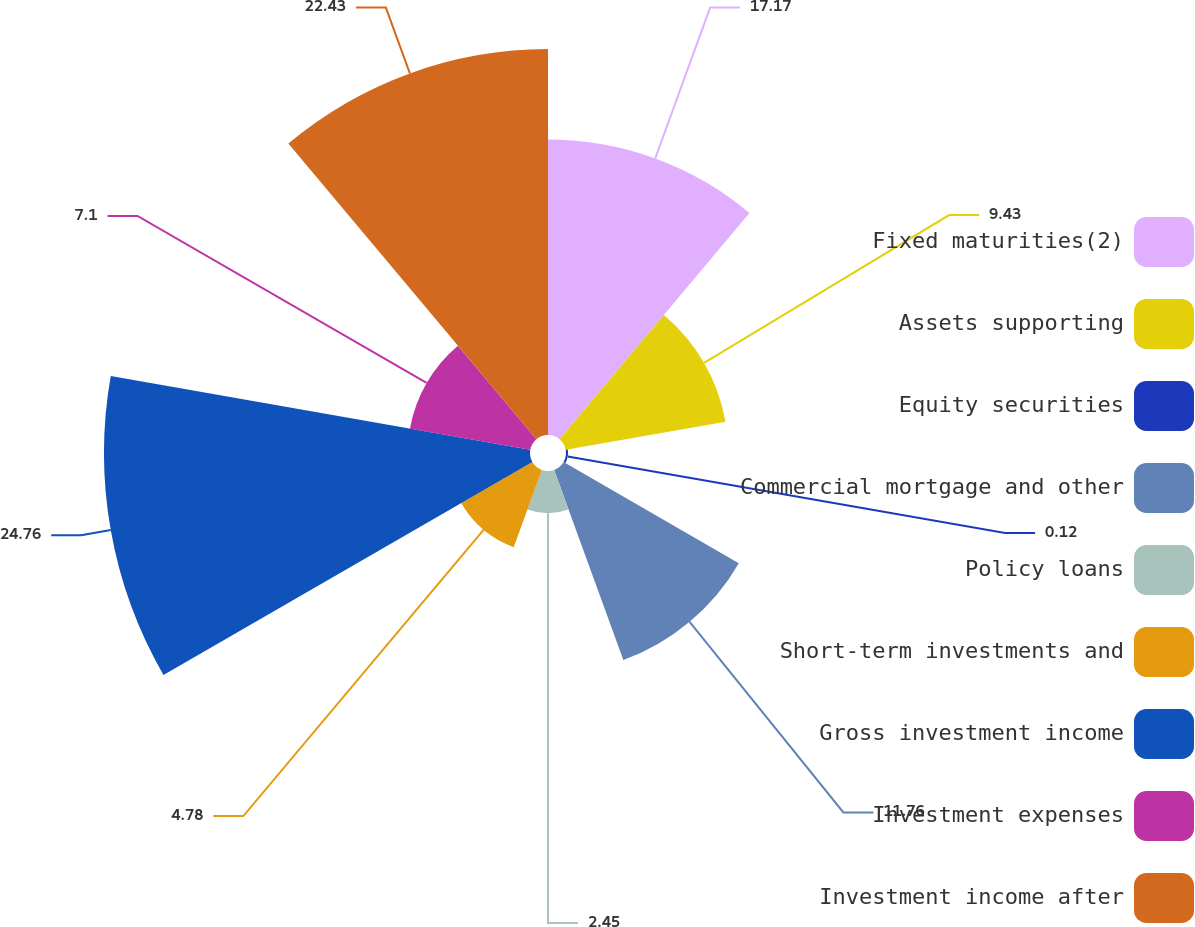Convert chart. <chart><loc_0><loc_0><loc_500><loc_500><pie_chart><fcel>Fixed maturities(2)<fcel>Assets supporting<fcel>Equity securities<fcel>Commercial mortgage and other<fcel>Policy loans<fcel>Short-term investments and<fcel>Gross investment income<fcel>Investment expenses<fcel>Investment income after<nl><fcel>17.17%<fcel>9.43%<fcel>0.12%<fcel>11.76%<fcel>2.45%<fcel>4.78%<fcel>24.76%<fcel>7.1%<fcel>22.43%<nl></chart> 